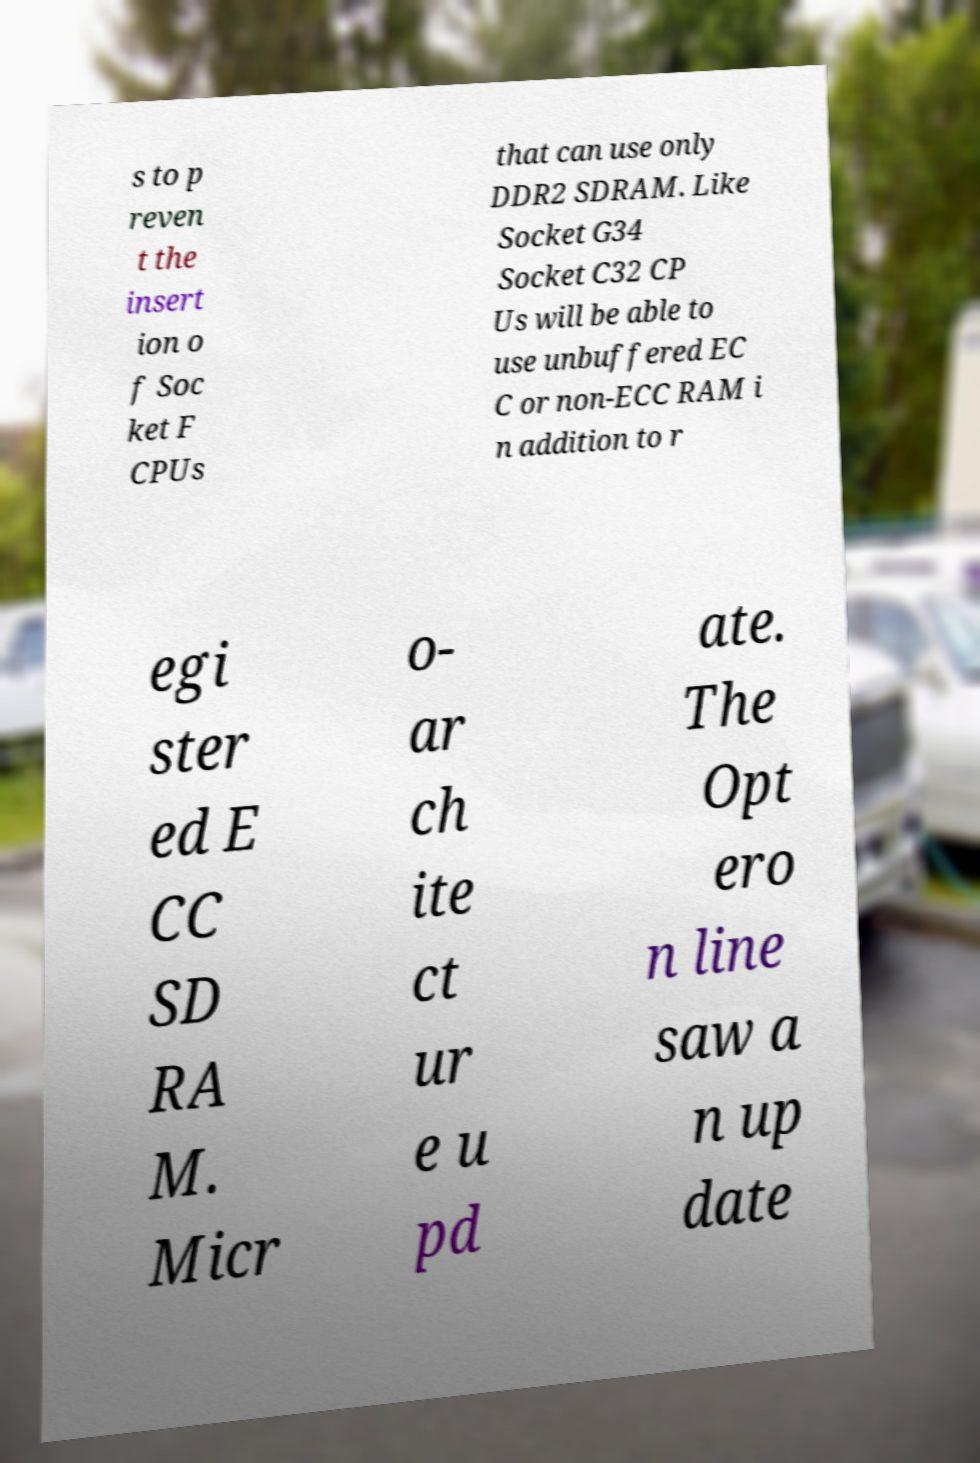Can you accurately transcribe the text from the provided image for me? s to p reven t the insert ion o f Soc ket F CPUs that can use only DDR2 SDRAM. Like Socket G34 Socket C32 CP Us will be able to use unbuffered EC C or non-ECC RAM i n addition to r egi ster ed E CC SD RA M. Micr o- ar ch ite ct ur e u pd ate. The Opt ero n line saw a n up date 